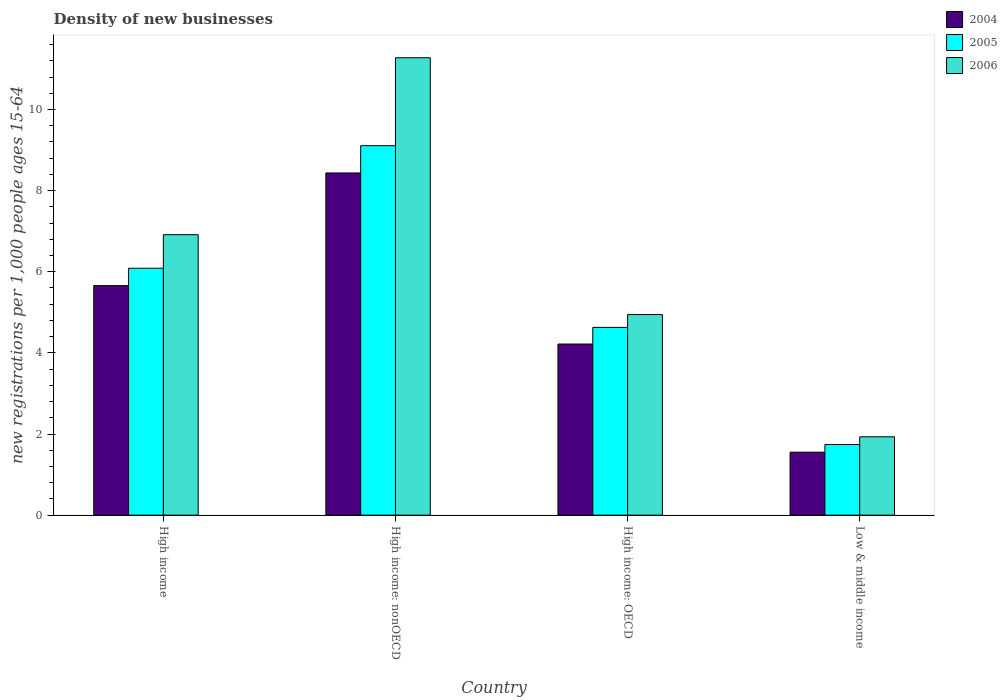Are the number of bars on each tick of the X-axis equal?
Provide a short and direct response. Yes. What is the label of the 2nd group of bars from the left?
Offer a very short reply. High income: nonOECD. In how many cases, is the number of bars for a given country not equal to the number of legend labels?
Keep it short and to the point. 0. What is the number of new registrations in 2005 in High income: nonOECD?
Your answer should be compact. 9.11. Across all countries, what is the maximum number of new registrations in 2005?
Offer a very short reply. 9.11. Across all countries, what is the minimum number of new registrations in 2006?
Offer a very short reply. 1.93. In which country was the number of new registrations in 2006 maximum?
Ensure brevity in your answer.  High income: nonOECD. What is the total number of new registrations in 2004 in the graph?
Provide a short and direct response. 19.87. What is the difference between the number of new registrations in 2006 in High income and that in Low & middle income?
Offer a very short reply. 4.98. What is the difference between the number of new registrations in 2004 in Low & middle income and the number of new registrations in 2005 in High income: nonOECD?
Provide a short and direct response. -7.56. What is the average number of new registrations in 2004 per country?
Give a very brief answer. 4.97. What is the difference between the number of new registrations of/in 2006 and number of new registrations of/in 2005 in High income: nonOECD?
Ensure brevity in your answer.  2.17. In how many countries, is the number of new registrations in 2005 greater than 6.4?
Provide a short and direct response. 1. What is the ratio of the number of new registrations in 2005 in High income to that in High income: OECD?
Make the answer very short. 1.32. Is the number of new registrations in 2004 in High income less than that in High income: nonOECD?
Provide a short and direct response. Yes. Is the difference between the number of new registrations in 2006 in High income: OECD and Low & middle income greater than the difference between the number of new registrations in 2005 in High income: OECD and Low & middle income?
Your response must be concise. Yes. What is the difference between the highest and the second highest number of new registrations in 2004?
Offer a terse response. 4.22. What is the difference between the highest and the lowest number of new registrations in 2004?
Offer a very short reply. 6.88. In how many countries, is the number of new registrations in 2004 greater than the average number of new registrations in 2004 taken over all countries?
Your response must be concise. 2. What does the 2nd bar from the left in High income represents?
Keep it short and to the point. 2005. Is it the case that in every country, the sum of the number of new registrations in 2005 and number of new registrations in 2006 is greater than the number of new registrations in 2004?
Provide a succinct answer. Yes. What is the difference between two consecutive major ticks on the Y-axis?
Provide a succinct answer. 2. Are the values on the major ticks of Y-axis written in scientific E-notation?
Give a very brief answer. No. Does the graph contain grids?
Make the answer very short. No. How many legend labels are there?
Provide a succinct answer. 3. What is the title of the graph?
Make the answer very short. Density of new businesses. Does "2003" appear as one of the legend labels in the graph?
Provide a succinct answer. No. What is the label or title of the X-axis?
Give a very brief answer. Country. What is the label or title of the Y-axis?
Keep it short and to the point. New registrations per 1,0 people ages 15-64. What is the new registrations per 1,000 people ages 15-64 of 2004 in High income?
Give a very brief answer. 5.66. What is the new registrations per 1,000 people ages 15-64 of 2005 in High income?
Offer a very short reply. 6.09. What is the new registrations per 1,000 people ages 15-64 of 2006 in High income?
Make the answer very short. 6.91. What is the new registrations per 1,000 people ages 15-64 in 2004 in High income: nonOECD?
Keep it short and to the point. 8.44. What is the new registrations per 1,000 people ages 15-64 in 2005 in High income: nonOECD?
Your answer should be compact. 9.11. What is the new registrations per 1,000 people ages 15-64 in 2006 in High income: nonOECD?
Keep it short and to the point. 11.28. What is the new registrations per 1,000 people ages 15-64 of 2004 in High income: OECD?
Your response must be concise. 4.22. What is the new registrations per 1,000 people ages 15-64 of 2005 in High income: OECD?
Keep it short and to the point. 4.63. What is the new registrations per 1,000 people ages 15-64 of 2006 in High income: OECD?
Offer a terse response. 4.94. What is the new registrations per 1,000 people ages 15-64 of 2004 in Low & middle income?
Ensure brevity in your answer.  1.55. What is the new registrations per 1,000 people ages 15-64 in 2005 in Low & middle income?
Offer a terse response. 1.74. What is the new registrations per 1,000 people ages 15-64 in 2006 in Low & middle income?
Offer a very short reply. 1.93. Across all countries, what is the maximum new registrations per 1,000 people ages 15-64 in 2004?
Your response must be concise. 8.44. Across all countries, what is the maximum new registrations per 1,000 people ages 15-64 of 2005?
Provide a succinct answer. 9.11. Across all countries, what is the maximum new registrations per 1,000 people ages 15-64 in 2006?
Your response must be concise. 11.28. Across all countries, what is the minimum new registrations per 1,000 people ages 15-64 of 2004?
Ensure brevity in your answer.  1.55. Across all countries, what is the minimum new registrations per 1,000 people ages 15-64 in 2005?
Make the answer very short. 1.74. Across all countries, what is the minimum new registrations per 1,000 people ages 15-64 in 2006?
Offer a terse response. 1.93. What is the total new registrations per 1,000 people ages 15-64 in 2004 in the graph?
Your answer should be compact. 19.87. What is the total new registrations per 1,000 people ages 15-64 of 2005 in the graph?
Offer a terse response. 21.57. What is the total new registrations per 1,000 people ages 15-64 in 2006 in the graph?
Your response must be concise. 25.07. What is the difference between the new registrations per 1,000 people ages 15-64 of 2004 in High income and that in High income: nonOECD?
Ensure brevity in your answer.  -2.78. What is the difference between the new registrations per 1,000 people ages 15-64 of 2005 in High income and that in High income: nonOECD?
Your answer should be compact. -3.02. What is the difference between the new registrations per 1,000 people ages 15-64 of 2006 in High income and that in High income: nonOECD?
Your answer should be very brief. -4.36. What is the difference between the new registrations per 1,000 people ages 15-64 in 2004 in High income and that in High income: OECD?
Your response must be concise. 1.44. What is the difference between the new registrations per 1,000 people ages 15-64 in 2005 in High income and that in High income: OECD?
Your response must be concise. 1.46. What is the difference between the new registrations per 1,000 people ages 15-64 of 2006 in High income and that in High income: OECD?
Make the answer very short. 1.97. What is the difference between the new registrations per 1,000 people ages 15-64 of 2004 in High income and that in Low & middle income?
Ensure brevity in your answer.  4.11. What is the difference between the new registrations per 1,000 people ages 15-64 in 2005 in High income and that in Low & middle income?
Your response must be concise. 4.35. What is the difference between the new registrations per 1,000 people ages 15-64 of 2006 in High income and that in Low & middle income?
Ensure brevity in your answer.  4.98. What is the difference between the new registrations per 1,000 people ages 15-64 of 2004 in High income: nonOECD and that in High income: OECD?
Give a very brief answer. 4.22. What is the difference between the new registrations per 1,000 people ages 15-64 of 2005 in High income: nonOECD and that in High income: OECD?
Your answer should be compact. 4.48. What is the difference between the new registrations per 1,000 people ages 15-64 of 2006 in High income: nonOECD and that in High income: OECD?
Provide a short and direct response. 6.33. What is the difference between the new registrations per 1,000 people ages 15-64 of 2004 in High income: nonOECD and that in Low & middle income?
Offer a very short reply. 6.88. What is the difference between the new registrations per 1,000 people ages 15-64 in 2005 in High income: nonOECD and that in Low & middle income?
Make the answer very short. 7.37. What is the difference between the new registrations per 1,000 people ages 15-64 in 2006 in High income: nonOECD and that in Low & middle income?
Provide a short and direct response. 9.34. What is the difference between the new registrations per 1,000 people ages 15-64 of 2004 in High income: OECD and that in Low & middle income?
Offer a very short reply. 2.67. What is the difference between the new registrations per 1,000 people ages 15-64 of 2005 in High income: OECD and that in Low & middle income?
Provide a short and direct response. 2.89. What is the difference between the new registrations per 1,000 people ages 15-64 of 2006 in High income: OECD and that in Low & middle income?
Give a very brief answer. 3.01. What is the difference between the new registrations per 1,000 people ages 15-64 of 2004 in High income and the new registrations per 1,000 people ages 15-64 of 2005 in High income: nonOECD?
Provide a succinct answer. -3.45. What is the difference between the new registrations per 1,000 people ages 15-64 in 2004 in High income and the new registrations per 1,000 people ages 15-64 in 2006 in High income: nonOECD?
Give a very brief answer. -5.62. What is the difference between the new registrations per 1,000 people ages 15-64 in 2005 in High income and the new registrations per 1,000 people ages 15-64 in 2006 in High income: nonOECD?
Your answer should be very brief. -5.19. What is the difference between the new registrations per 1,000 people ages 15-64 of 2004 in High income and the new registrations per 1,000 people ages 15-64 of 2005 in High income: OECD?
Offer a terse response. 1.03. What is the difference between the new registrations per 1,000 people ages 15-64 of 2004 in High income and the new registrations per 1,000 people ages 15-64 of 2006 in High income: OECD?
Ensure brevity in your answer.  0.71. What is the difference between the new registrations per 1,000 people ages 15-64 in 2005 in High income and the new registrations per 1,000 people ages 15-64 in 2006 in High income: OECD?
Your response must be concise. 1.14. What is the difference between the new registrations per 1,000 people ages 15-64 in 2004 in High income and the new registrations per 1,000 people ages 15-64 in 2005 in Low & middle income?
Your answer should be very brief. 3.92. What is the difference between the new registrations per 1,000 people ages 15-64 in 2004 in High income and the new registrations per 1,000 people ages 15-64 in 2006 in Low & middle income?
Your response must be concise. 3.73. What is the difference between the new registrations per 1,000 people ages 15-64 of 2005 in High income and the new registrations per 1,000 people ages 15-64 of 2006 in Low & middle income?
Give a very brief answer. 4.16. What is the difference between the new registrations per 1,000 people ages 15-64 of 2004 in High income: nonOECD and the new registrations per 1,000 people ages 15-64 of 2005 in High income: OECD?
Your response must be concise. 3.81. What is the difference between the new registrations per 1,000 people ages 15-64 of 2004 in High income: nonOECD and the new registrations per 1,000 people ages 15-64 of 2006 in High income: OECD?
Ensure brevity in your answer.  3.49. What is the difference between the new registrations per 1,000 people ages 15-64 of 2005 in High income: nonOECD and the new registrations per 1,000 people ages 15-64 of 2006 in High income: OECD?
Provide a succinct answer. 4.16. What is the difference between the new registrations per 1,000 people ages 15-64 in 2004 in High income: nonOECD and the new registrations per 1,000 people ages 15-64 in 2005 in Low & middle income?
Give a very brief answer. 6.69. What is the difference between the new registrations per 1,000 people ages 15-64 in 2004 in High income: nonOECD and the new registrations per 1,000 people ages 15-64 in 2006 in Low & middle income?
Your response must be concise. 6.5. What is the difference between the new registrations per 1,000 people ages 15-64 in 2005 in High income: nonOECD and the new registrations per 1,000 people ages 15-64 in 2006 in Low & middle income?
Your answer should be very brief. 7.18. What is the difference between the new registrations per 1,000 people ages 15-64 of 2004 in High income: OECD and the new registrations per 1,000 people ages 15-64 of 2005 in Low & middle income?
Make the answer very short. 2.48. What is the difference between the new registrations per 1,000 people ages 15-64 of 2004 in High income: OECD and the new registrations per 1,000 people ages 15-64 of 2006 in Low & middle income?
Offer a terse response. 2.29. What is the difference between the new registrations per 1,000 people ages 15-64 in 2005 in High income: OECD and the new registrations per 1,000 people ages 15-64 in 2006 in Low & middle income?
Your response must be concise. 2.7. What is the average new registrations per 1,000 people ages 15-64 of 2004 per country?
Provide a succinct answer. 4.97. What is the average new registrations per 1,000 people ages 15-64 in 2005 per country?
Keep it short and to the point. 5.39. What is the average new registrations per 1,000 people ages 15-64 of 2006 per country?
Offer a terse response. 6.27. What is the difference between the new registrations per 1,000 people ages 15-64 of 2004 and new registrations per 1,000 people ages 15-64 of 2005 in High income?
Provide a succinct answer. -0.43. What is the difference between the new registrations per 1,000 people ages 15-64 in 2004 and new registrations per 1,000 people ages 15-64 in 2006 in High income?
Provide a short and direct response. -1.26. What is the difference between the new registrations per 1,000 people ages 15-64 in 2005 and new registrations per 1,000 people ages 15-64 in 2006 in High income?
Make the answer very short. -0.83. What is the difference between the new registrations per 1,000 people ages 15-64 of 2004 and new registrations per 1,000 people ages 15-64 of 2005 in High income: nonOECD?
Ensure brevity in your answer.  -0.67. What is the difference between the new registrations per 1,000 people ages 15-64 in 2004 and new registrations per 1,000 people ages 15-64 in 2006 in High income: nonOECD?
Give a very brief answer. -2.84. What is the difference between the new registrations per 1,000 people ages 15-64 of 2005 and new registrations per 1,000 people ages 15-64 of 2006 in High income: nonOECD?
Your response must be concise. -2.17. What is the difference between the new registrations per 1,000 people ages 15-64 in 2004 and new registrations per 1,000 people ages 15-64 in 2005 in High income: OECD?
Your response must be concise. -0.41. What is the difference between the new registrations per 1,000 people ages 15-64 in 2004 and new registrations per 1,000 people ages 15-64 in 2006 in High income: OECD?
Provide a short and direct response. -0.73. What is the difference between the new registrations per 1,000 people ages 15-64 of 2005 and new registrations per 1,000 people ages 15-64 of 2006 in High income: OECD?
Your answer should be very brief. -0.32. What is the difference between the new registrations per 1,000 people ages 15-64 of 2004 and new registrations per 1,000 people ages 15-64 of 2005 in Low & middle income?
Provide a succinct answer. -0.19. What is the difference between the new registrations per 1,000 people ages 15-64 in 2004 and new registrations per 1,000 people ages 15-64 in 2006 in Low & middle income?
Your response must be concise. -0.38. What is the difference between the new registrations per 1,000 people ages 15-64 in 2005 and new registrations per 1,000 people ages 15-64 in 2006 in Low & middle income?
Provide a short and direct response. -0.19. What is the ratio of the new registrations per 1,000 people ages 15-64 in 2004 in High income to that in High income: nonOECD?
Give a very brief answer. 0.67. What is the ratio of the new registrations per 1,000 people ages 15-64 of 2005 in High income to that in High income: nonOECD?
Your answer should be compact. 0.67. What is the ratio of the new registrations per 1,000 people ages 15-64 in 2006 in High income to that in High income: nonOECD?
Provide a succinct answer. 0.61. What is the ratio of the new registrations per 1,000 people ages 15-64 of 2004 in High income to that in High income: OECD?
Keep it short and to the point. 1.34. What is the ratio of the new registrations per 1,000 people ages 15-64 in 2005 in High income to that in High income: OECD?
Your answer should be compact. 1.31. What is the ratio of the new registrations per 1,000 people ages 15-64 in 2006 in High income to that in High income: OECD?
Provide a short and direct response. 1.4. What is the ratio of the new registrations per 1,000 people ages 15-64 in 2004 in High income to that in Low & middle income?
Provide a succinct answer. 3.64. What is the ratio of the new registrations per 1,000 people ages 15-64 in 2005 in High income to that in Low & middle income?
Offer a terse response. 3.5. What is the ratio of the new registrations per 1,000 people ages 15-64 of 2006 in High income to that in Low & middle income?
Your response must be concise. 3.58. What is the ratio of the new registrations per 1,000 people ages 15-64 of 2004 in High income: nonOECD to that in High income: OECD?
Offer a terse response. 2. What is the ratio of the new registrations per 1,000 people ages 15-64 in 2005 in High income: nonOECD to that in High income: OECD?
Give a very brief answer. 1.97. What is the ratio of the new registrations per 1,000 people ages 15-64 of 2006 in High income: nonOECD to that in High income: OECD?
Keep it short and to the point. 2.28. What is the ratio of the new registrations per 1,000 people ages 15-64 of 2004 in High income: nonOECD to that in Low & middle income?
Provide a succinct answer. 5.43. What is the ratio of the new registrations per 1,000 people ages 15-64 of 2005 in High income: nonOECD to that in Low & middle income?
Give a very brief answer. 5.23. What is the ratio of the new registrations per 1,000 people ages 15-64 in 2006 in High income: nonOECD to that in Low & middle income?
Your answer should be very brief. 5.84. What is the ratio of the new registrations per 1,000 people ages 15-64 in 2004 in High income: OECD to that in Low & middle income?
Keep it short and to the point. 2.72. What is the ratio of the new registrations per 1,000 people ages 15-64 of 2005 in High income: OECD to that in Low & middle income?
Provide a succinct answer. 2.66. What is the ratio of the new registrations per 1,000 people ages 15-64 in 2006 in High income: OECD to that in Low & middle income?
Make the answer very short. 2.56. What is the difference between the highest and the second highest new registrations per 1,000 people ages 15-64 of 2004?
Give a very brief answer. 2.78. What is the difference between the highest and the second highest new registrations per 1,000 people ages 15-64 in 2005?
Ensure brevity in your answer.  3.02. What is the difference between the highest and the second highest new registrations per 1,000 people ages 15-64 in 2006?
Ensure brevity in your answer.  4.36. What is the difference between the highest and the lowest new registrations per 1,000 people ages 15-64 of 2004?
Provide a short and direct response. 6.88. What is the difference between the highest and the lowest new registrations per 1,000 people ages 15-64 of 2005?
Your response must be concise. 7.37. What is the difference between the highest and the lowest new registrations per 1,000 people ages 15-64 of 2006?
Keep it short and to the point. 9.34. 